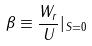Convert formula to latex. <formula><loc_0><loc_0><loc_500><loc_500>\beta \equiv \frac { W _ { r } } { U } | _ { S = 0 }</formula> 